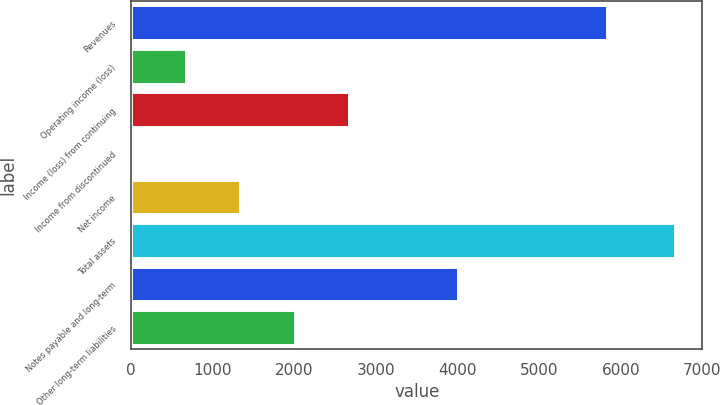Convert chart to OTSL. <chart><loc_0><loc_0><loc_500><loc_500><bar_chart><fcel>Revenues<fcel>Operating income (loss)<fcel>Income (loss) from continuing<fcel>Income from discontinued<fcel>Net income<fcel>Total assets<fcel>Notes payable and long-term<fcel>Other long-term liabilities<nl><fcel>5836<fcel>669.83<fcel>2668.88<fcel>3.48<fcel>1336.18<fcel>6667<fcel>4001.58<fcel>2002.53<nl></chart> 